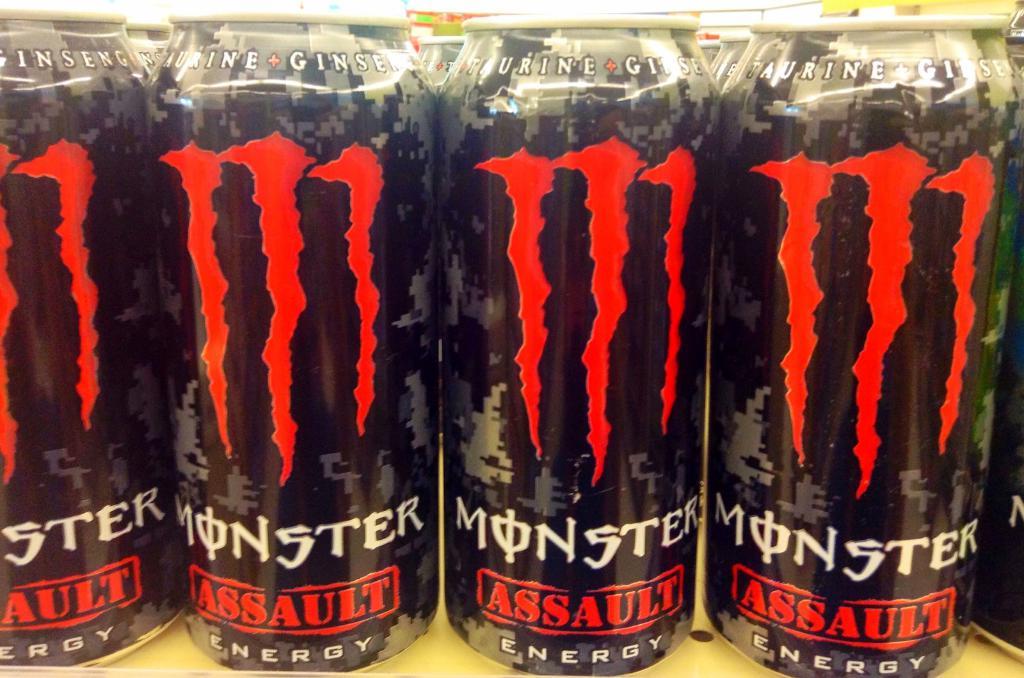What is the brand of energy drink shown here?
Keep it short and to the point. Monster. What version of monster is this?
Provide a succinct answer. Assault. 